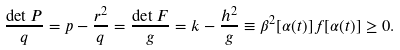Convert formula to latex. <formula><loc_0><loc_0><loc_500><loc_500>\frac { \det P } { q } = p - \frac { r ^ { 2 } } { q } = \frac { \det F } { g } = k - \frac { h ^ { 2 } } { g } \equiv \beta ^ { 2 } [ \alpha ( t ) ] f [ \alpha ( t ) ] \geq 0 .</formula> 